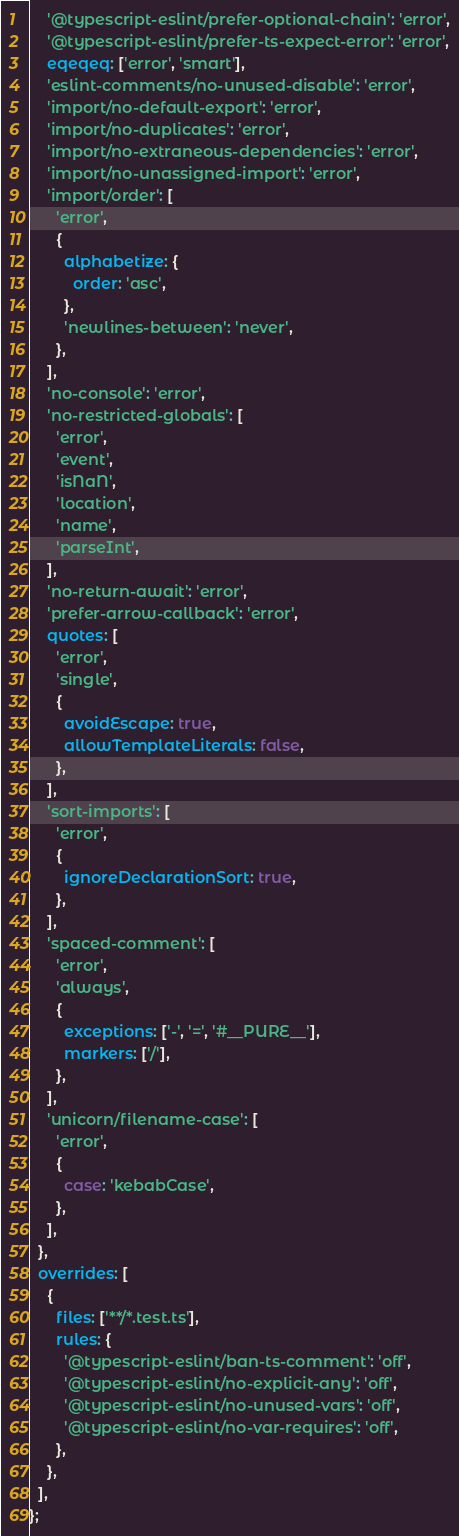Convert code to text. <code><loc_0><loc_0><loc_500><loc_500><_JavaScript_>    '@typescript-eslint/prefer-optional-chain': 'error',
    '@typescript-eslint/prefer-ts-expect-error': 'error',
    eqeqeq: ['error', 'smart'],
    'eslint-comments/no-unused-disable': 'error',
    'import/no-default-export': 'error',
    'import/no-duplicates': 'error',
    'import/no-extraneous-dependencies': 'error',
    'import/no-unassigned-import': 'error',
    'import/order': [
      'error',
      {
        alphabetize: {
          order: 'asc',
        },
        'newlines-between': 'never',
      },
    ],
    'no-console': 'error',
    'no-restricted-globals': [
      'error',
      'event',
      'isNaN',
      'location',
      'name',
      'parseInt',
    ],
    'no-return-await': 'error',
    'prefer-arrow-callback': 'error',
    quotes: [
      'error',
      'single',
      {
        avoidEscape: true,
        allowTemplateLiterals: false,
      },
    ],
    'sort-imports': [
      'error',
      {
        ignoreDeclarationSort: true,
      },
    ],
    'spaced-comment': [
      'error',
      'always',
      {
        exceptions: ['-', '=', '#__PURE__'],
        markers: ['/'],
      },
    ],
    'unicorn/filename-case': [
      'error',
      {
        case: 'kebabCase',
      },
    ],
  },
  overrides: [
    {
      files: ['**/*.test.ts'],
      rules: {
        '@typescript-eslint/ban-ts-comment': 'off',
        '@typescript-eslint/no-explicit-any': 'off',
        '@typescript-eslint/no-unused-vars': 'off',
        '@typescript-eslint/no-var-requires': 'off',
      },
    },
  ],
};
</code> 